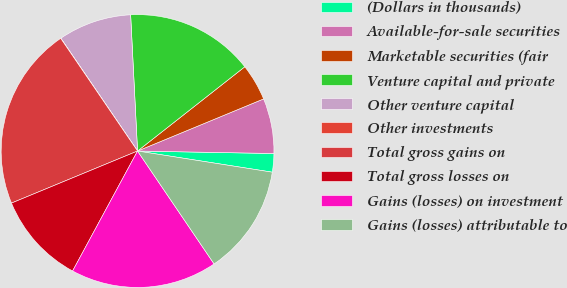<chart> <loc_0><loc_0><loc_500><loc_500><pie_chart><fcel>(Dollars in thousands)<fcel>Available-for-sale securities<fcel>Marketable securities (fair<fcel>Venture capital and private<fcel>Other venture capital<fcel>Other investments<fcel>Total gross gains on<fcel>Total gross losses on<fcel>Gains (losses) on investment<fcel>Gains (losses) attributable to<nl><fcel>2.19%<fcel>6.53%<fcel>4.36%<fcel>15.21%<fcel>8.7%<fcel>0.02%<fcel>21.71%<fcel>10.87%<fcel>17.38%<fcel>13.04%<nl></chart> 